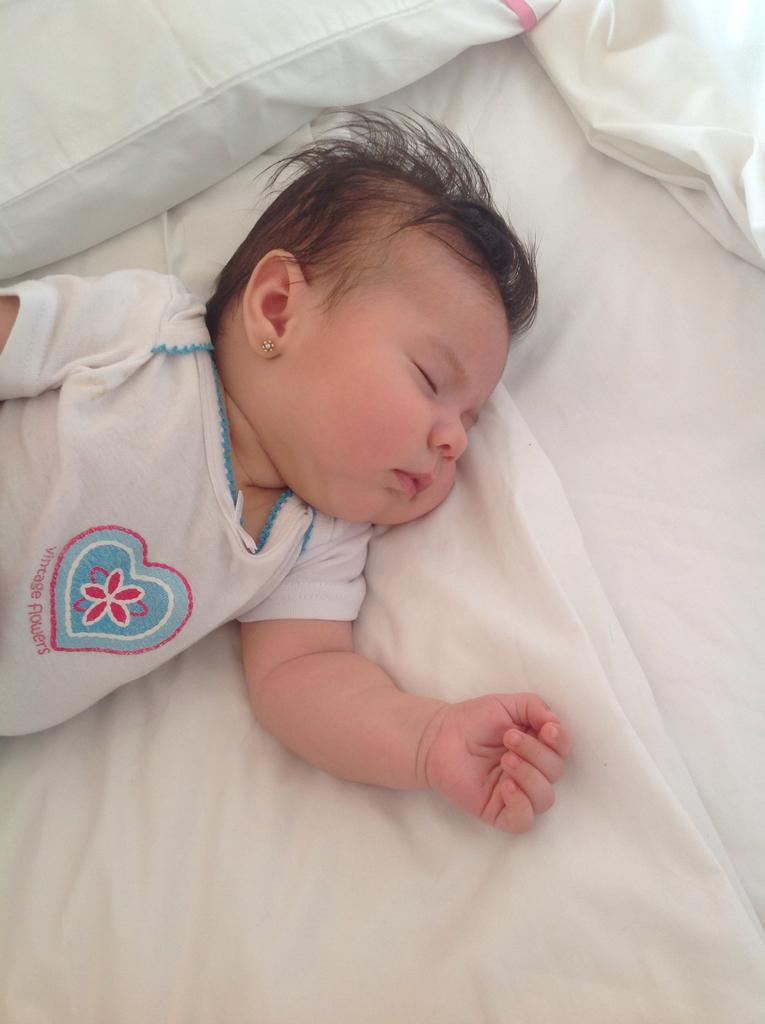What is the main subject of the picture? The main subject of the picture is a baby. What is the baby wearing in the image? The baby is wearing a white T-shirt. What is the baby doing in the picture? The baby is sleeping. Can you describe any objects in the image besides the baby? There is a white pillow in the left top corner of the image. What type of ice can be seen melting on the baby's teeth in the image? There is no ice or teeth visible in the image; the baby is wearing a white T-shirt and is sleeping. 